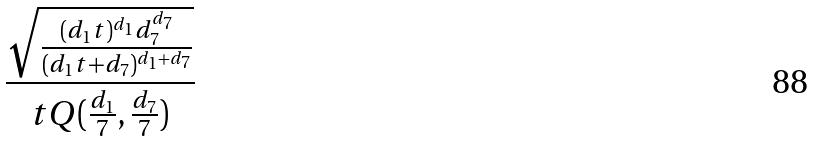<formula> <loc_0><loc_0><loc_500><loc_500>\frac { \sqrt { \frac { ( d _ { 1 } t ) ^ { d _ { 1 } } d _ { 7 } ^ { d _ { 7 } } } { ( d _ { 1 } t + d _ { 7 } ) ^ { d _ { 1 } + d _ { 7 } } } } } { t Q ( \frac { d _ { 1 } } { 7 } , \frac { d _ { 7 } } { 7 } ) }</formula> 